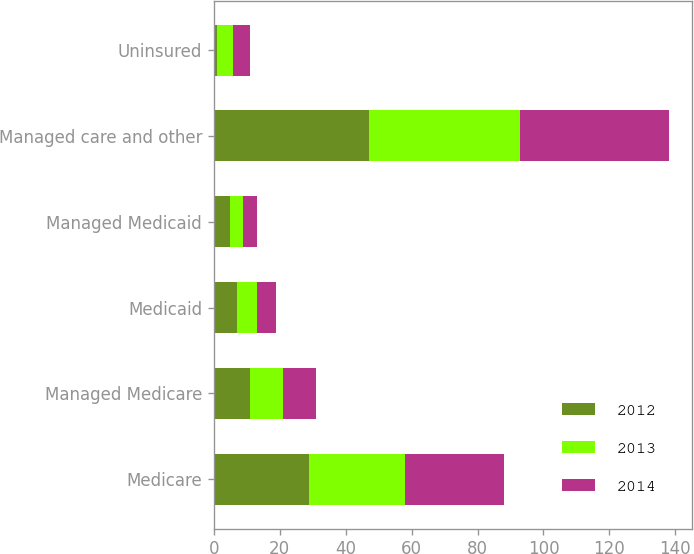Convert chart. <chart><loc_0><loc_0><loc_500><loc_500><stacked_bar_chart><ecel><fcel>Medicare<fcel>Managed Medicare<fcel>Medicaid<fcel>Managed Medicaid<fcel>Managed care and other<fcel>Uninsured<nl><fcel>2012<fcel>29<fcel>11<fcel>7<fcel>5<fcel>47<fcel>1<nl><fcel>2013<fcel>29<fcel>10<fcel>6<fcel>4<fcel>46<fcel>5<nl><fcel>2014<fcel>30<fcel>10<fcel>6<fcel>4<fcel>45<fcel>5<nl></chart> 